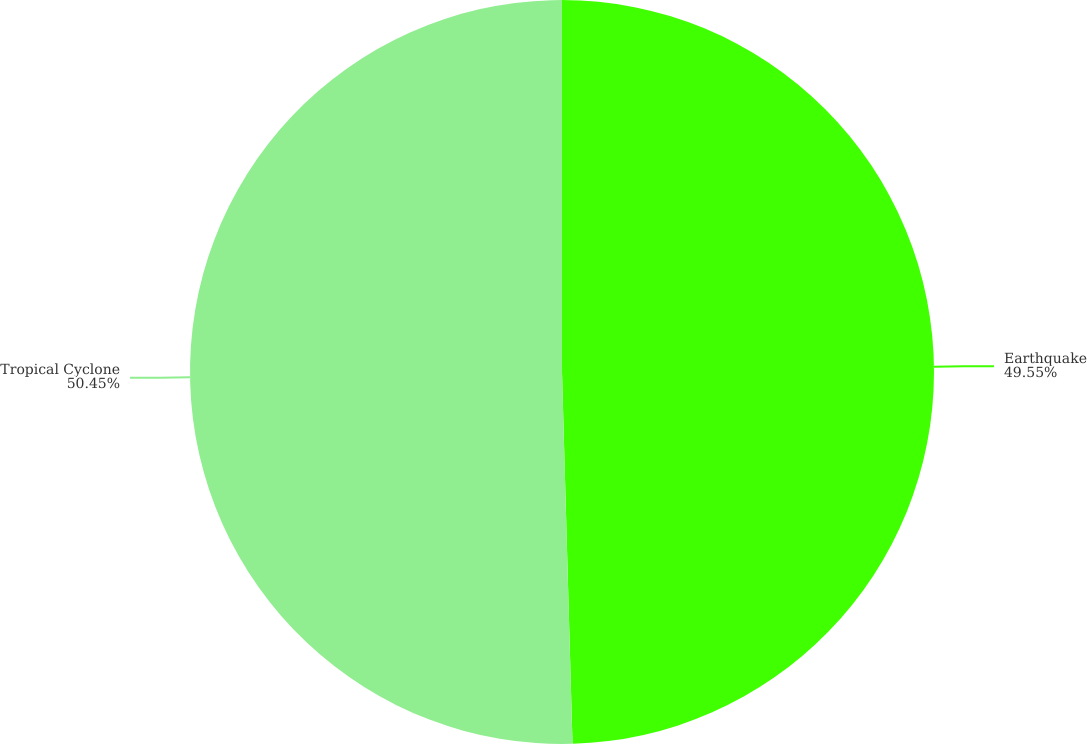<chart> <loc_0><loc_0><loc_500><loc_500><pie_chart><fcel>Earthquake<fcel>Tropical Cyclone<nl><fcel>49.55%<fcel>50.45%<nl></chart> 